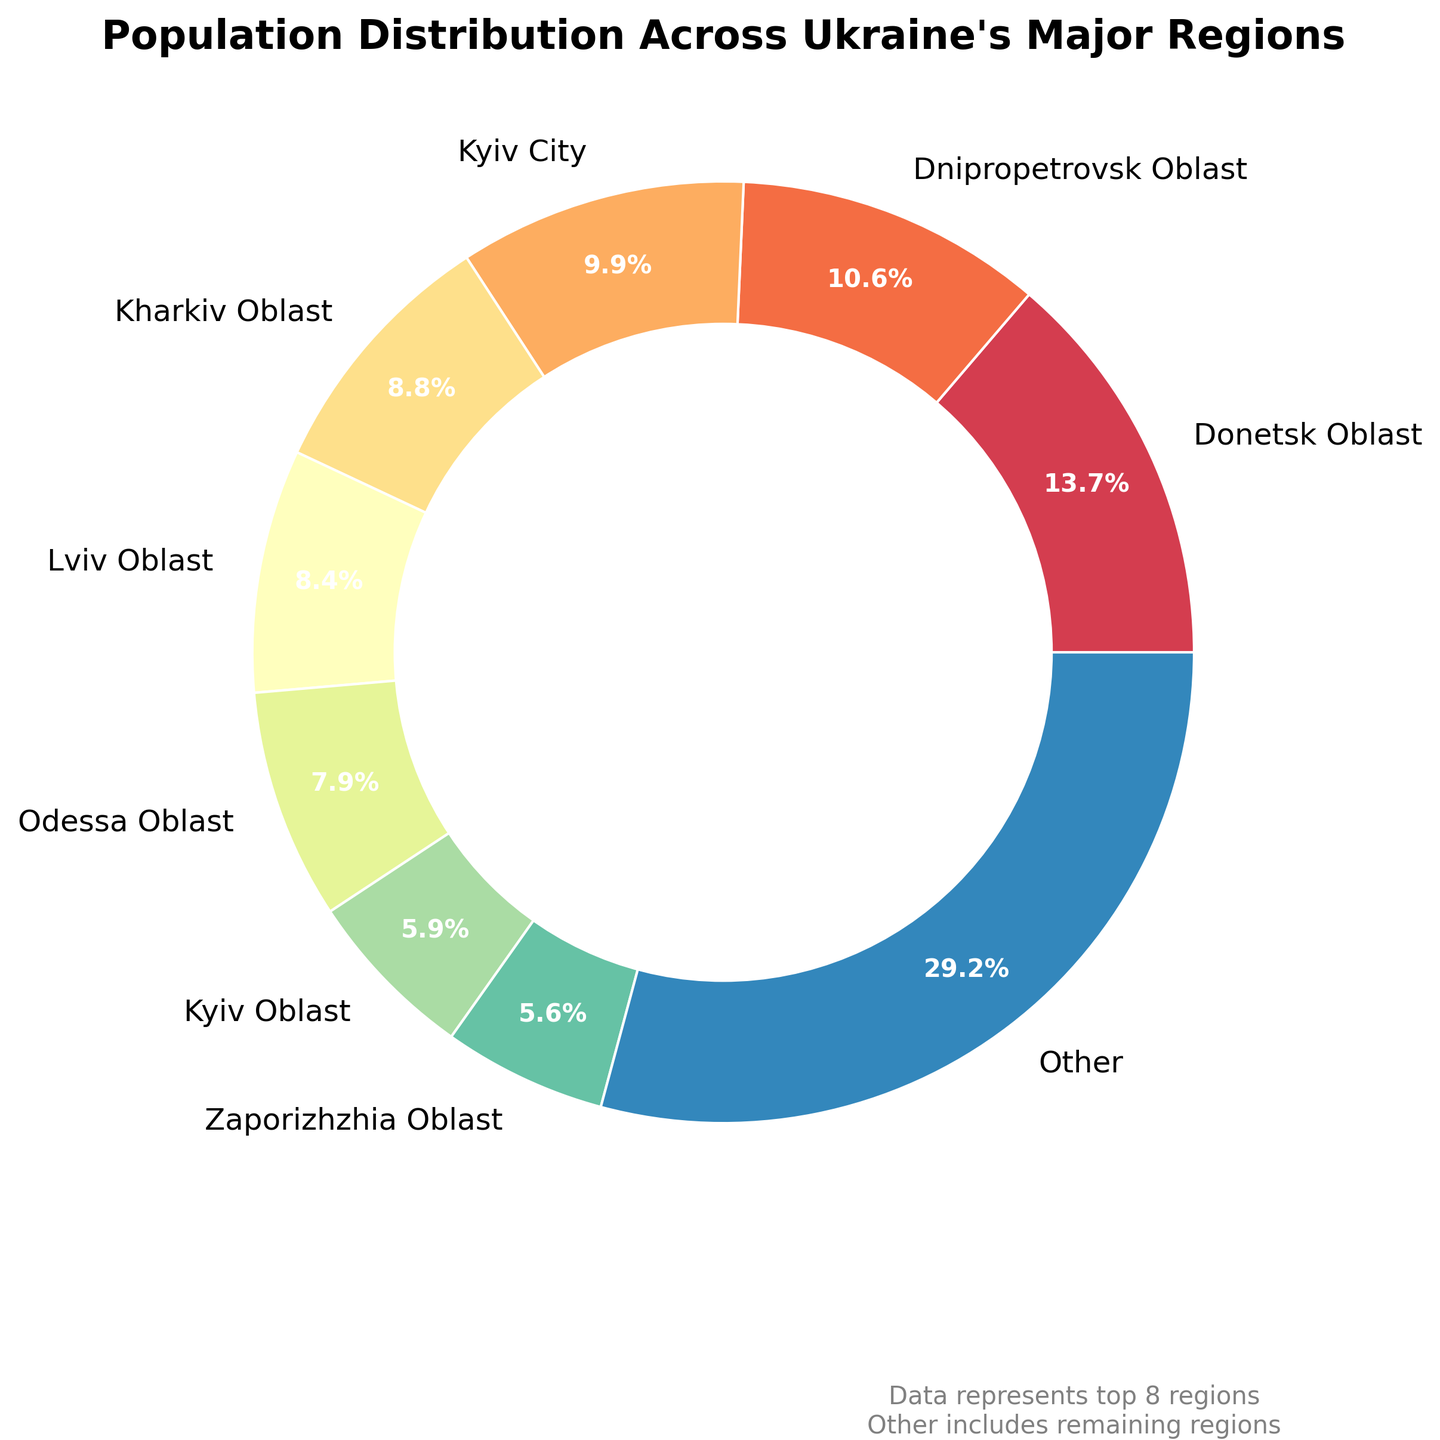Which region has the highest population percentage? By looking at the chart, Donetsk Oblast has the largest slice, implying it has the highest population percentage.
Answer: Donetsk Oblast How much larger is the population percentage of Donetsk Oblast compared to Kyiv City? The percentage for Donetsk Oblast is larger than that of Kyiv City. Subtract Kyiv City's percentage from Donetsk Oblast's percentage to find the difference.
Answer: Approximately 5.6% What is the combined population percentage of Kyiv City and Dnipropetrovsk Oblast? Add the percentages of Kyiv City and Dnipropetrovsk Oblast. Both regions' slices can be identified and combined for a cumulative total.
Answer: Approximately 16.7% What color represents Lviv Oblast in the pie chart? Observing the color segments of the pie chart, locate Lviv Oblast by its label to identify its color.
Answer: Light green Which regions apart from the top 8 are grouped together as 'Other'? By examining the pie chart, regions not identified in the top 8 segments are grouped together as 'Other'.
Answer: Zhytomyr, Khmelnytskyi, Cherkasy, Mykolaiv, Sumy, and others How much larger is the combined population percentage of Donetsk and Kharkiv Oblasts compared to Odessa Oblast? Find the combined population percentage of Donetsk and Kharkiv Oblasts and subtract Odessa Oblast's percentage from it.
Answer: Approximately 20.3% Which region in the top 8 has the lowest population percentage? Look at the pie chart and identify the smallest slice among the labeled top 8 regions.
Answer: Kyiv Oblast What is the visual attribute of the 'Other' segment compared to the 'Zaporizhzhia Oblast'? Compare the relative size and color of the 'Other' segment to the 'Zaporizhzhia Oblast' slice in the pie chart.
Answer: 'Other' is larger and might have a different shade How does the population percentage of Kharkiv Oblast compare to the total percentage of 'Other' regions? Compare the size of the slice representing Kharkiv Oblast with the aggregation of the 'Other' regions slice.
Answer: Kharkiv Oblast has a higher percentage Does the Kyiv City population percentage exceed 10% of the total? Check the percentage label for Kyiv City and see if it is above 10%.
Answer: No 